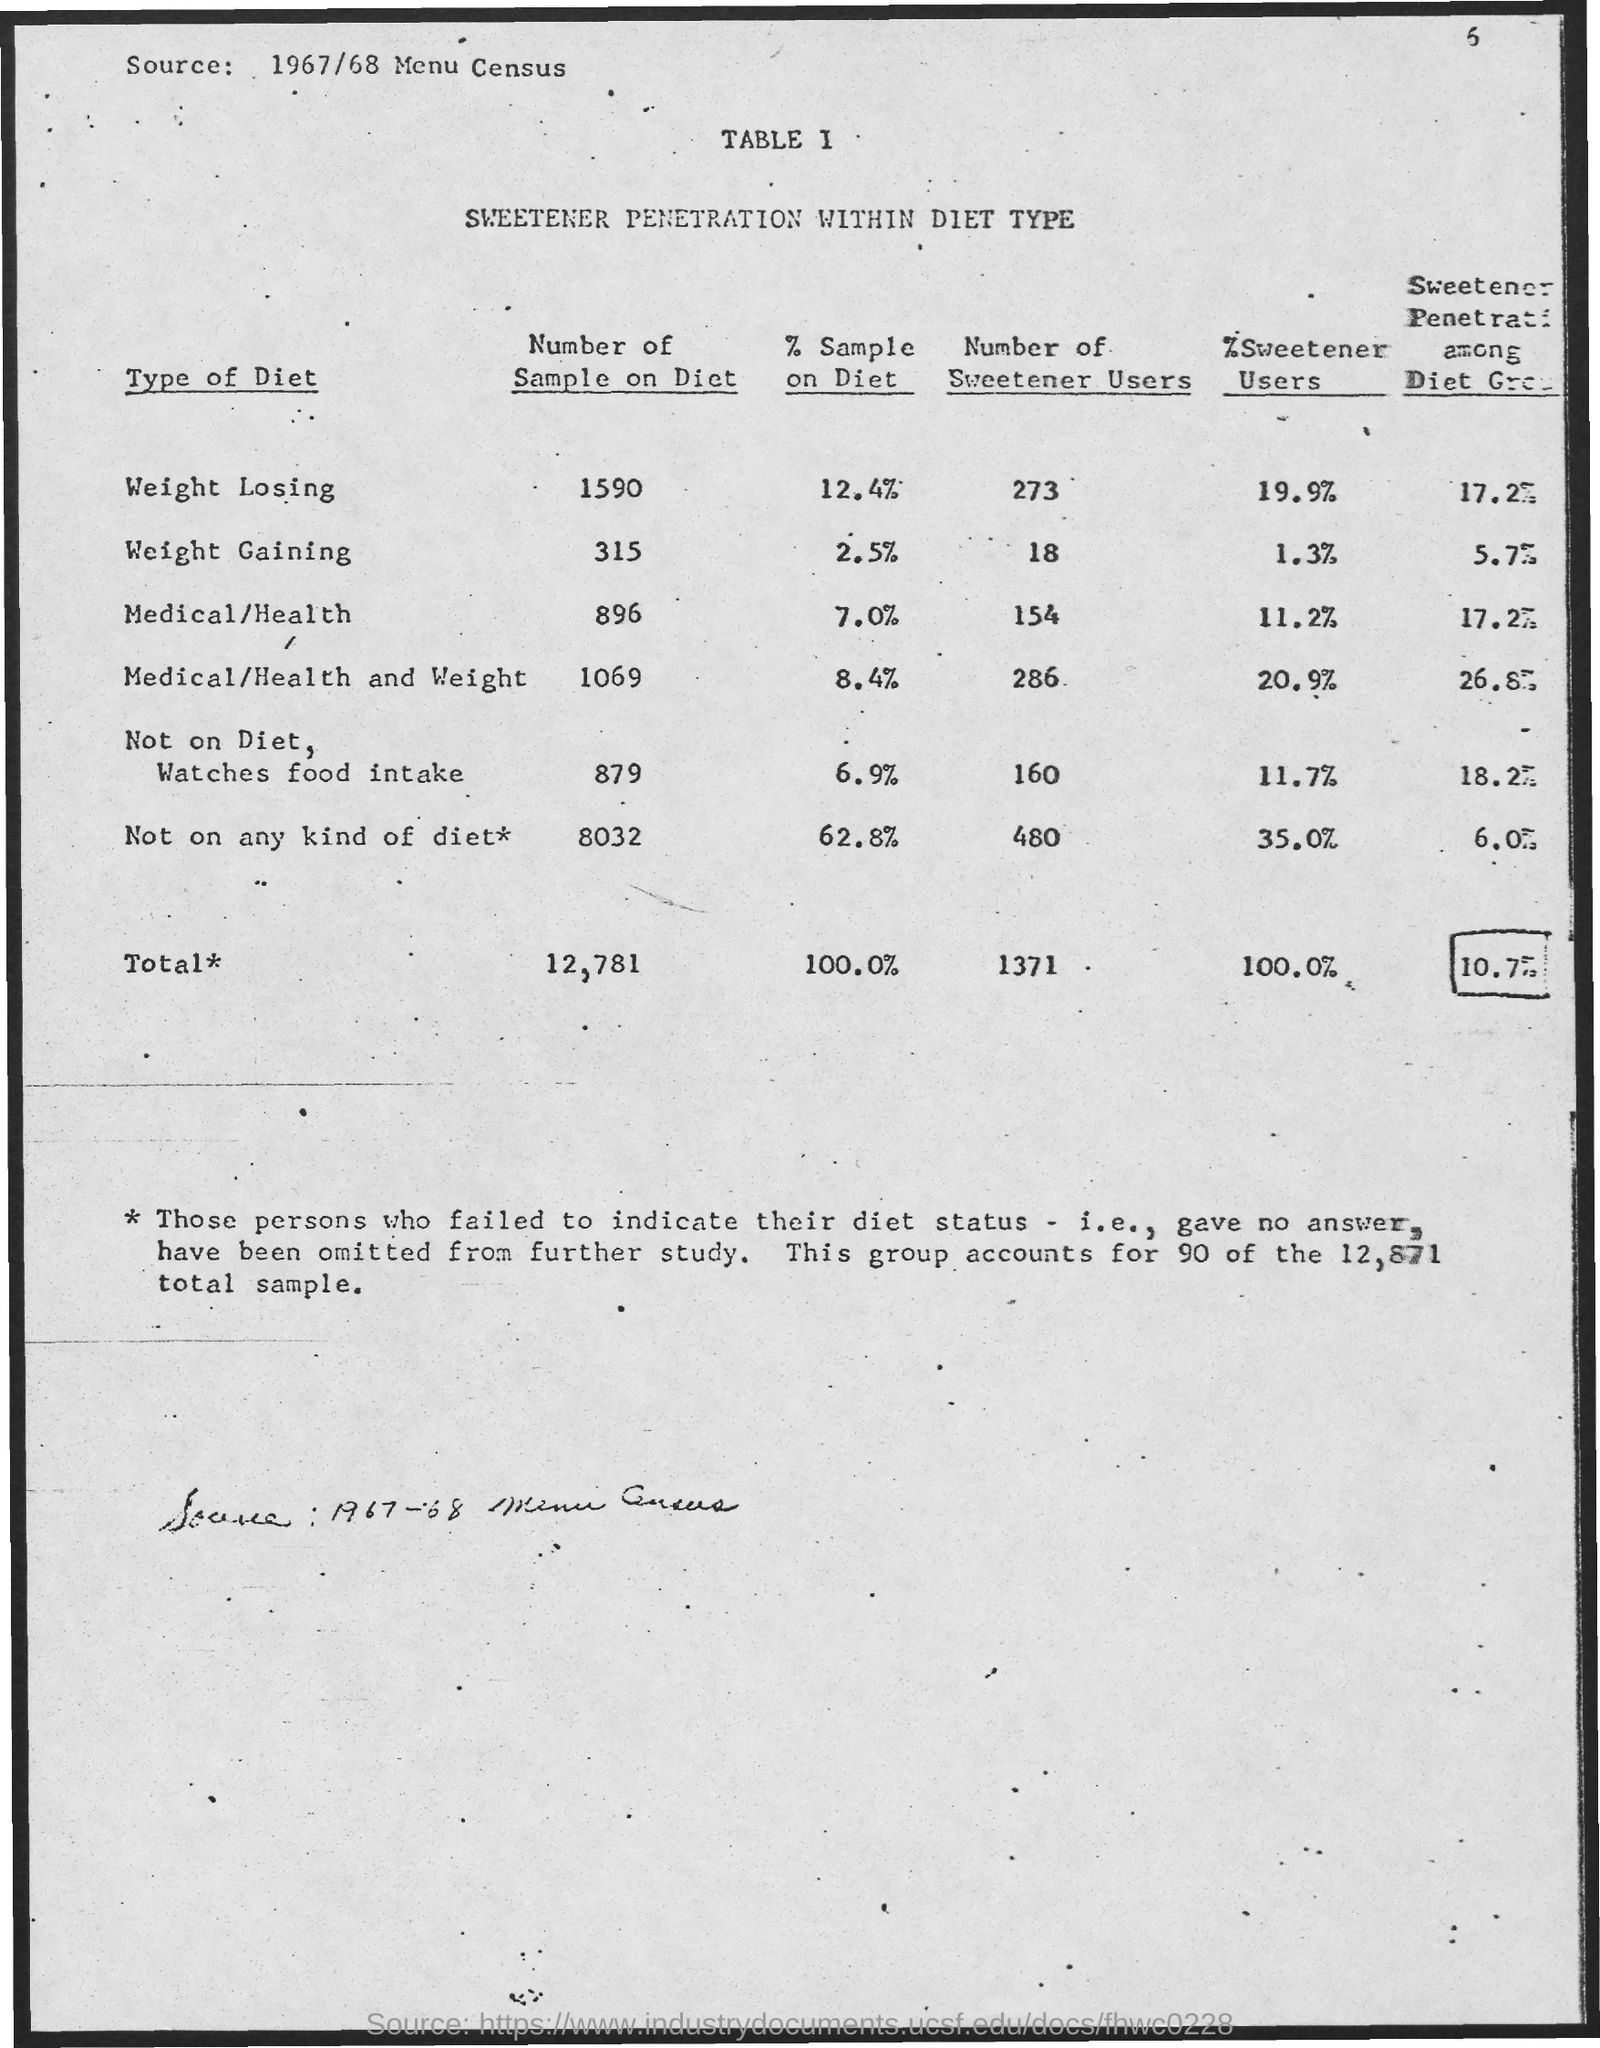What is the total number of sample on Diet?
Keep it short and to the point. 12,781. 